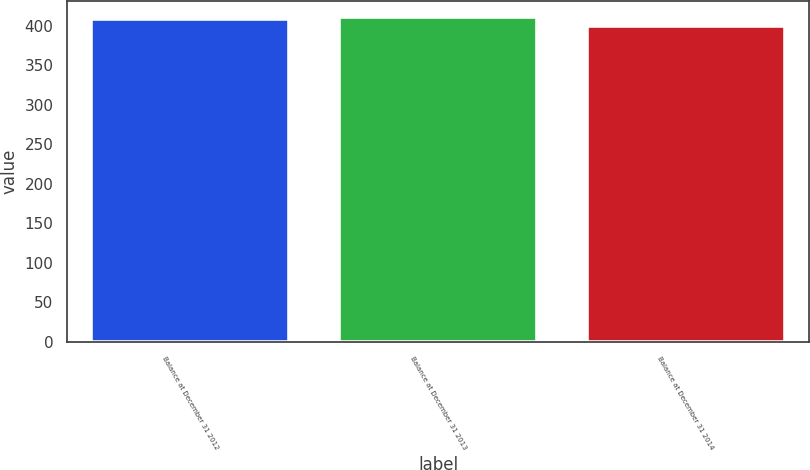Convert chart to OTSL. <chart><loc_0><loc_0><loc_500><loc_500><bar_chart><fcel>Balance at December 31 2012<fcel>Balance at December 31 2013<fcel>Balance at December 31 2014<nl><fcel>408<fcel>411<fcel>400<nl></chart> 